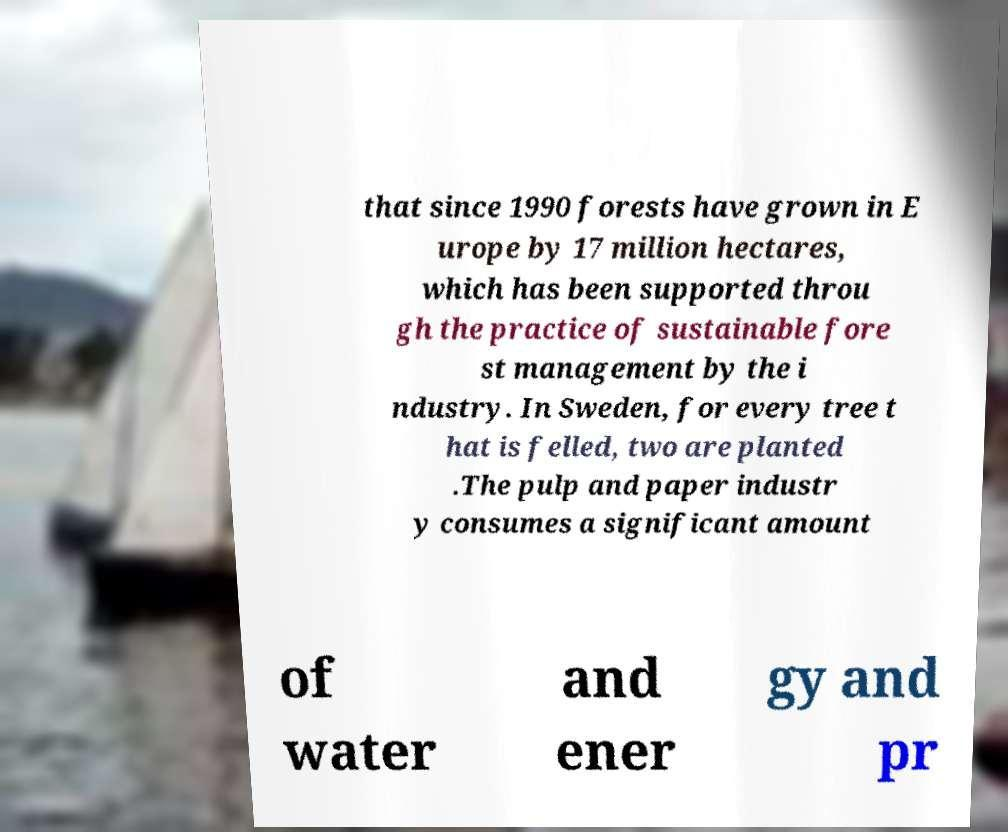Please identify and transcribe the text found in this image. that since 1990 forests have grown in E urope by 17 million hectares, which has been supported throu gh the practice of sustainable fore st management by the i ndustry. In Sweden, for every tree t hat is felled, two are planted .The pulp and paper industr y consumes a significant amount of water and ener gy and pr 